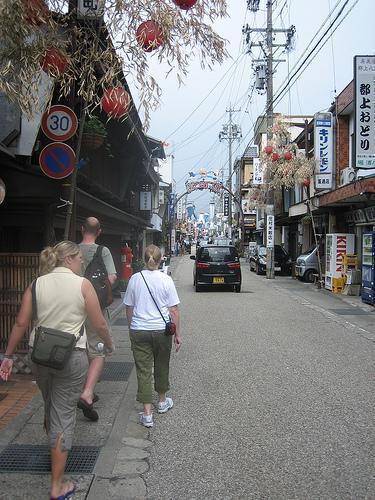How many cars are shown?
Give a very brief answer. 3. How many trees are shown?
Give a very brief answer. 2. How many travel bags do you see?
Give a very brief answer. 3. 